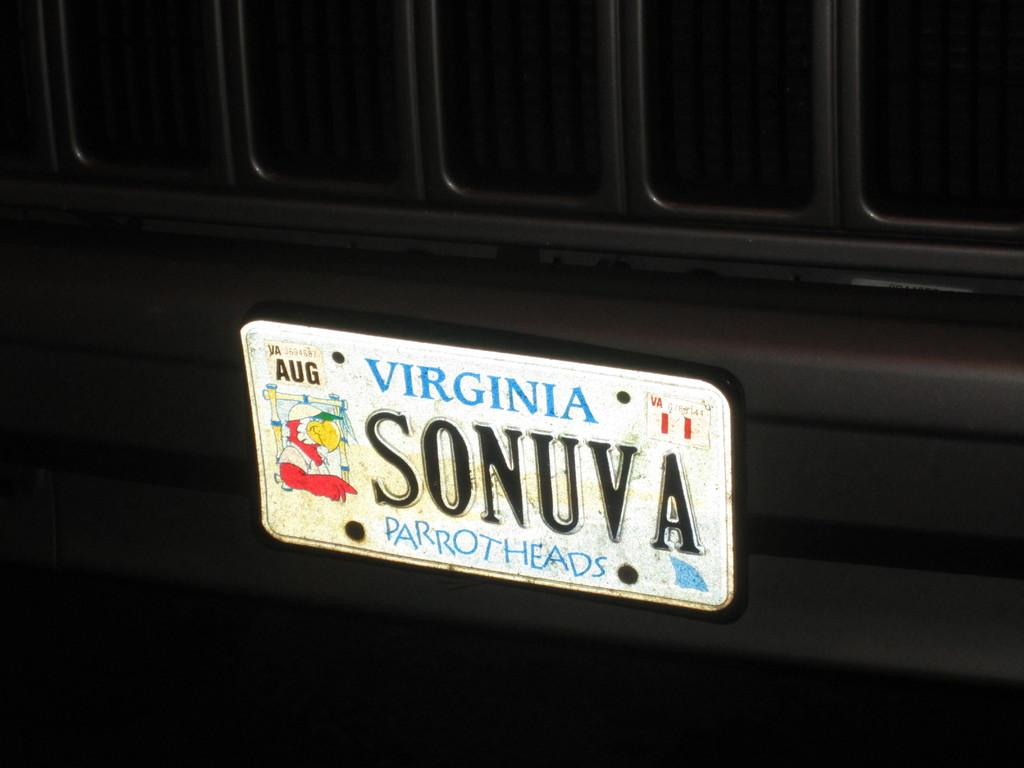<image>
Share a concise interpretation of the image provided. License plate from Virginia that says parrot heads. 